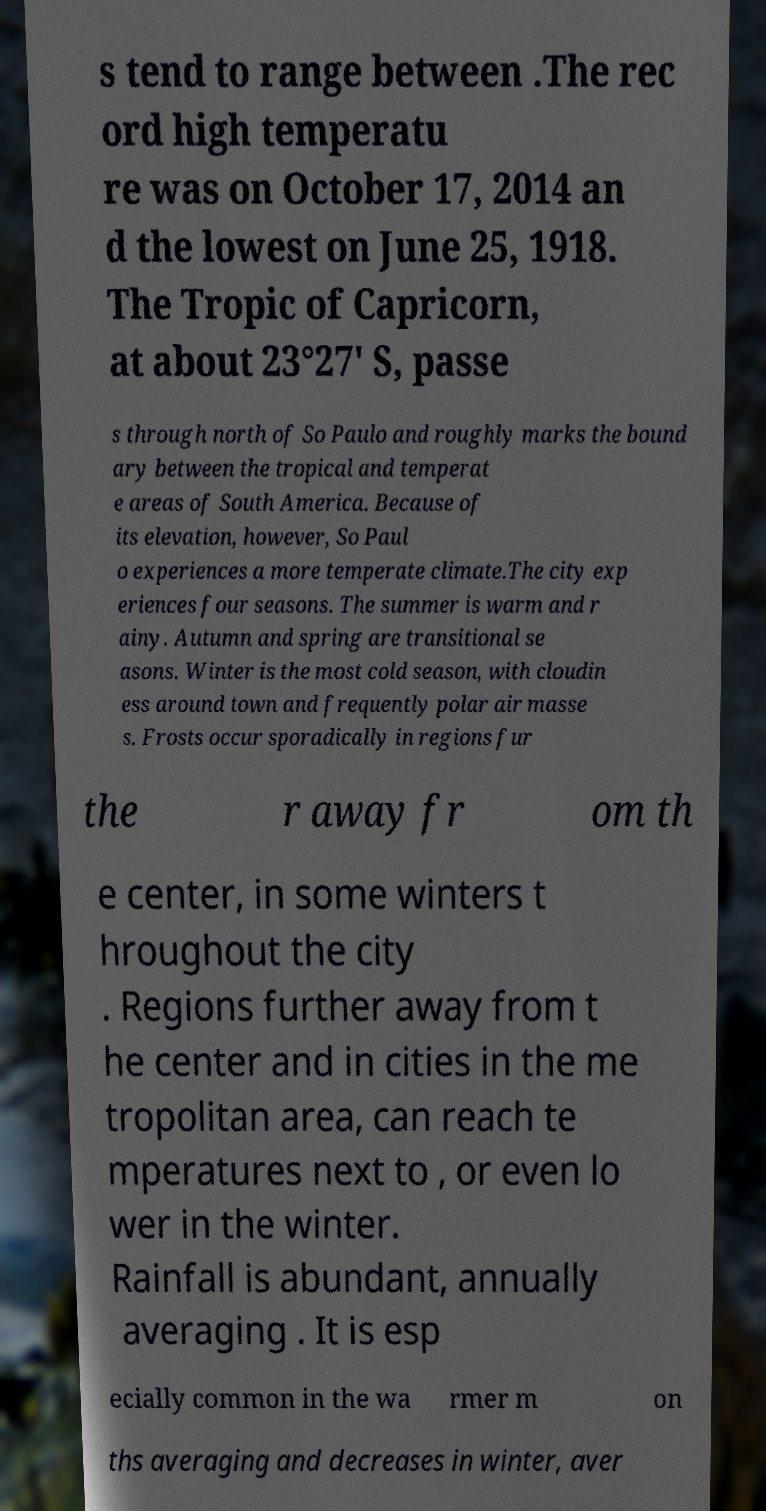Please read and relay the text visible in this image. What does it say? s tend to range between .The rec ord high temperatu re was on October 17, 2014 an d the lowest on June 25, 1918. The Tropic of Capricorn, at about 23°27' S, passe s through north of So Paulo and roughly marks the bound ary between the tropical and temperat e areas of South America. Because of its elevation, however, So Paul o experiences a more temperate climate.The city exp eriences four seasons. The summer is warm and r ainy. Autumn and spring are transitional se asons. Winter is the most cold season, with cloudin ess around town and frequently polar air masse s. Frosts occur sporadically in regions fur the r away fr om th e center, in some winters t hroughout the city . Regions further away from t he center and in cities in the me tropolitan area, can reach te mperatures next to , or even lo wer in the winter. Rainfall is abundant, annually averaging . It is esp ecially common in the wa rmer m on ths averaging and decreases in winter, aver 